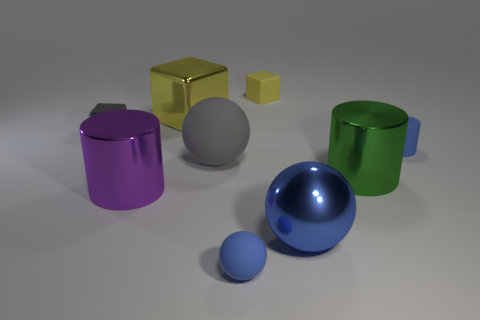Subtract all cubes. How many objects are left? 6 Add 3 yellow shiny things. How many yellow shiny things exist? 4 Subtract 0 brown cylinders. How many objects are left? 9 Subtract all big gray things. Subtract all small spheres. How many objects are left? 7 Add 1 purple cylinders. How many purple cylinders are left? 2 